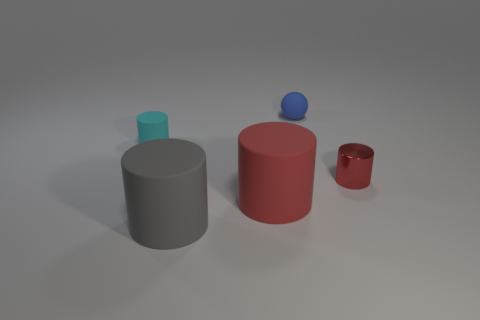Is there anything else that has the same material as the small red object?
Offer a very short reply. No. What material is the cylinder that is to the right of the gray matte thing and on the left side of the tiny rubber sphere?
Provide a short and direct response. Rubber. Are the gray thing and the small red cylinder made of the same material?
Your answer should be very brief. No. What material is the red cylinder that is in front of the tiny red metallic cylinder?
Your response must be concise. Rubber. There is a rubber cylinder behind the red matte cylinder that is to the right of the cyan thing; what size is it?
Your answer should be compact. Small. Does the small metallic thing have the same color as the big cylinder that is behind the gray cylinder?
Your answer should be very brief. Yes. What number of other objects are the same material as the blue ball?
Give a very brief answer. 3. There is a small object that is the same material as the small ball; what shape is it?
Keep it short and to the point. Cylinder. Is there anything else that is the same color as the tiny metallic cylinder?
Your answer should be very brief. Yes. Is the number of big red objects that are in front of the blue object greater than the number of large purple cubes?
Ensure brevity in your answer.  Yes. 